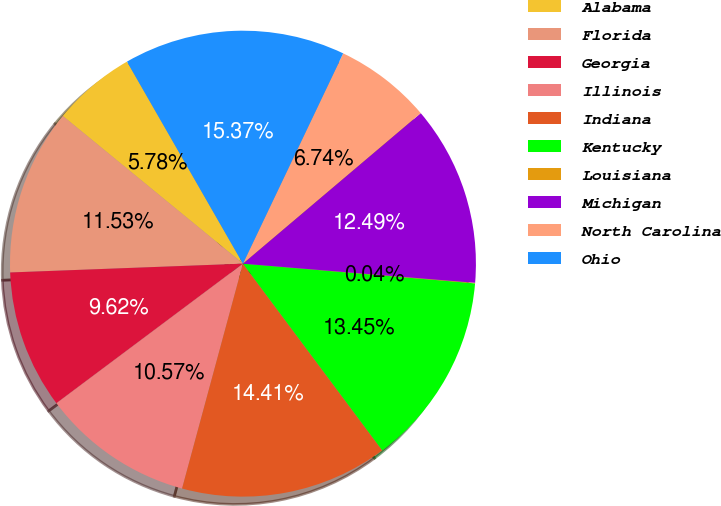Convert chart. <chart><loc_0><loc_0><loc_500><loc_500><pie_chart><fcel>Alabama<fcel>Florida<fcel>Georgia<fcel>Illinois<fcel>Indiana<fcel>Kentucky<fcel>Louisiana<fcel>Michigan<fcel>North Carolina<fcel>Ohio<nl><fcel>5.78%<fcel>11.53%<fcel>9.62%<fcel>10.57%<fcel>14.41%<fcel>13.45%<fcel>0.04%<fcel>12.49%<fcel>6.74%<fcel>15.37%<nl></chart> 